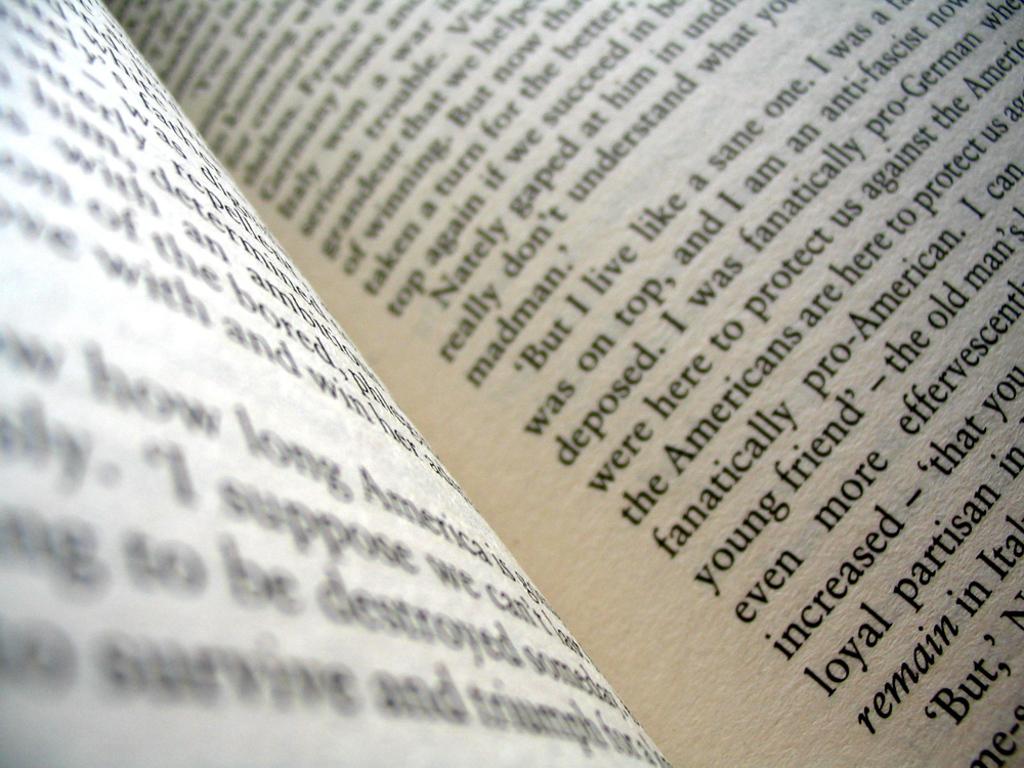What is the first word of the last paragraph on the right page?
Offer a terse response. But. 